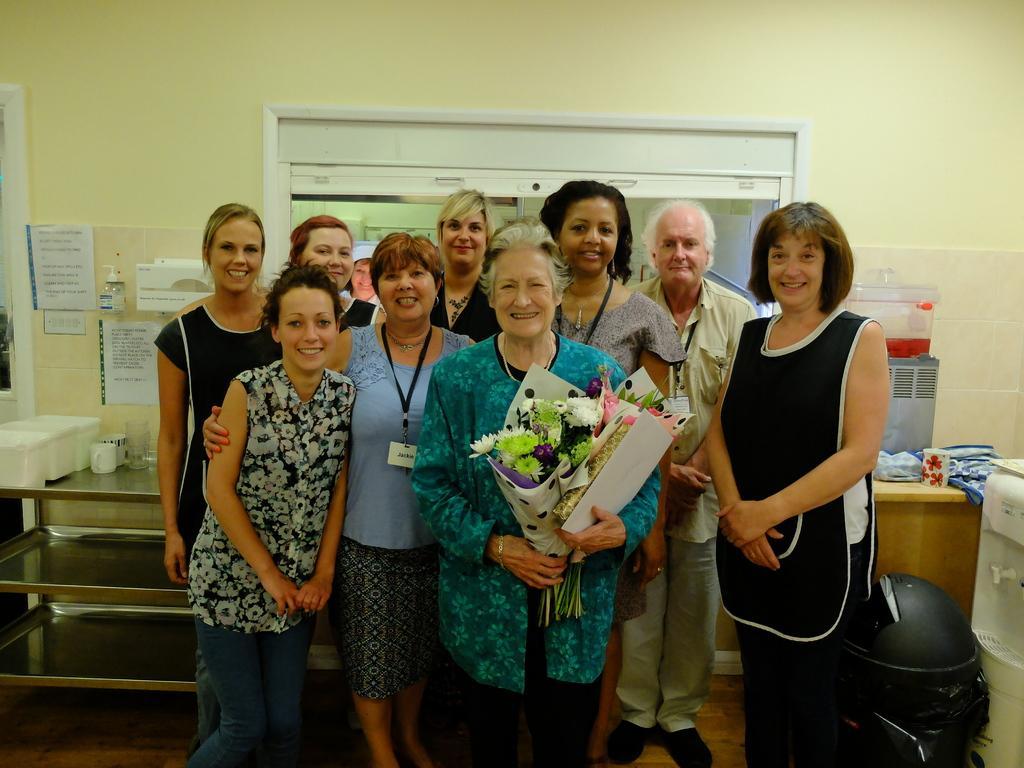In one or two sentences, can you explain what this image depicts? In the middle of the image there is a lady with blue dress is standing and holding the bouquet in her hands. Behind her there are few ladies and also there is a man standing. To the left side of the image there is a table with white boxes, cops and glasses. Behind them there is a wall with tiles and few papers on it. To the left corner of the image there is a door. To the right side of the image there is a water filter, table with cup and few items on it. Behind them there are is a wall with glass window. And to the top of the image there is a wall. 